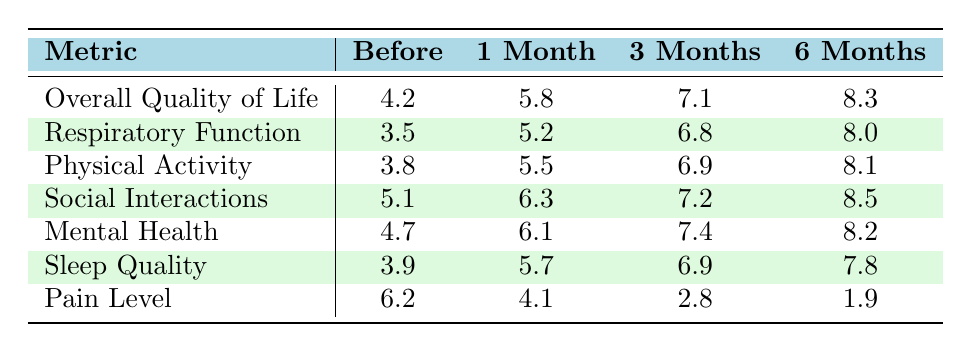What was the overall quality of life score before the procedure? The table shows that the overall quality of life score before the procedure was 4.2.
Answer: 4.2 What is the respiratory function score 3 months after the procedure? According to the table, the respiratory function score 3 months after the procedure is 6.8.
Answer: 6.8 What is the difference in pain level between before the procedure and 6 months after? The pain level before the procedure was 6.2 and 6 months after it dropped to 1.9. The difference is 6.2 - 1.9 = 4.3.
Answer: 4.3 What is the average score for mental health across all time points? The mental health scores across the time points are 4.7, 6.1, 7.4, and 8.2. The sum of these scores is 26.4, and there are 4 time points, so the average is 26.4 / 4 = 6.6.
Answer: 6.6 Is the physical activity score the highest one recorded in the table? Comparing the physical activity score of 8.1 at 6 months with other scores, 8.5 for social interactions is higher, so the answer is no.
Answer: No How much did the overall quality of life score increase from before the procedure to 1 month after? The overall quality of life score before the procedure was 4.2, and 1 month after, it increased to 5.8. The increase is 5.8 - 4.2 = 1.6.
Answer: 1.6 Did the sleep quality score improve from before the procedure to 3 months after? Before the procedure, the sleep quality score was 3.9, and it increased to 6.9 three months after, indicating an improvement.
Answer: Yes What was the lowest pain level recorded in the table? The pain level recorded after 6 months was 1.9, which is the lowest compared to the other values.
Answer: 1.9 What is the trend of overall quality of life scores from before the procedure to 6 months after? The overall quality of life scores increased consecutively from 4.2 to 5.8 (1 month), 7.1 (3 months), and 8.3 (6 months), indicating a positive trend.
Answer: Increasing How does the social interactions score change from 1 month to 3 months after the procedure? The social interactions score at 1 month was 6.3 and increased to 7.2 at 3 months, indicating improvement of 7.2 - 6.3 = 0.9.
Answer: 0.9 